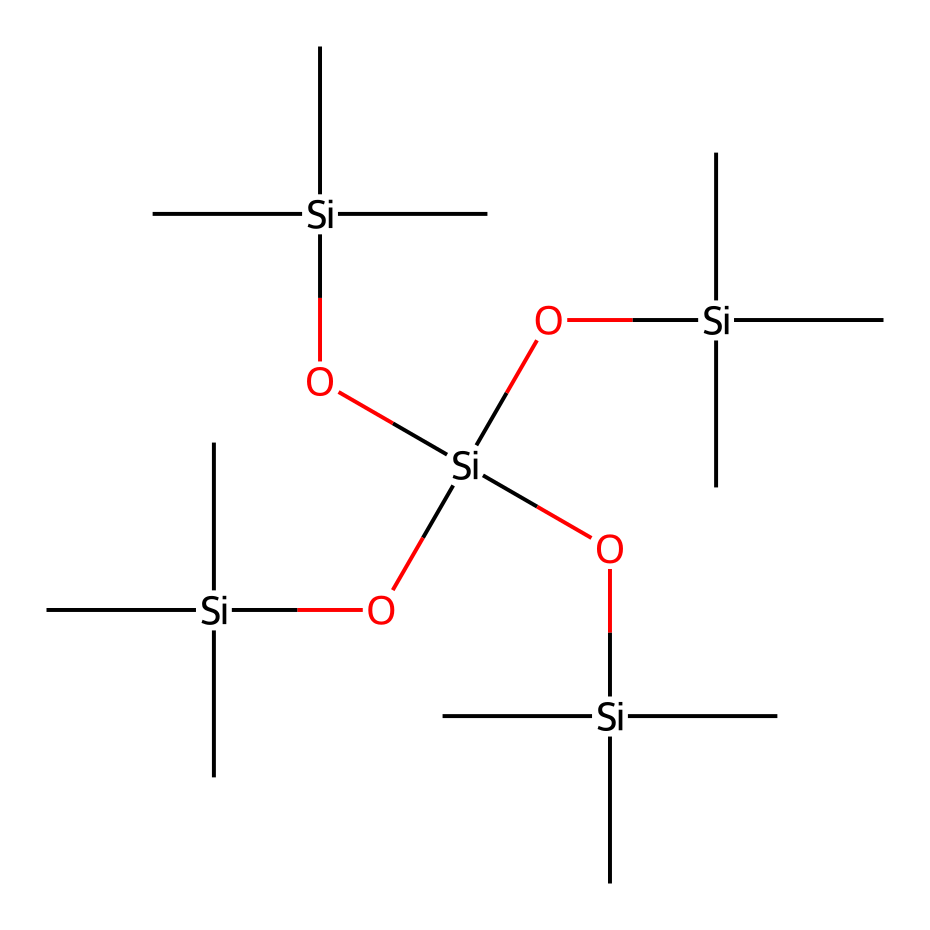What is the central atom of this organosilicon compound? In the provided SMILES representation, the central atom that is repeatedly mentioned is silicon (Si), as indicated by the repeating occurrences of [Si].
Answer: silicon How many silicon atoms are present in this structure? By examining the SMILES, the [Si] notation appears five times, indicating there are five silicon atoms present in the overall structure.
Answer: five What type of functional groups are present in this organosilicon compound? The SMILES representation includes the notation O which represents hydroxyl (–OH) functional groups attached to the silicon atoms, indicating the presence of silanol groups.
Answer: silanol What feature contributes to its photo-resistant properties in makeup? The silicon-oxygen bonds (Si-O) in this organosilicon compound provide stability and durability, contributing to its resistance to degradation under light exposure, which is essential for long-lasting makeup.
Answer: silicon-oxygen bonds How many carbon atoms are present in the structure? By analyzing the substituents attached to each silicon, each [Si](C)(C)C indicates three carbon atoms. Since there are four such silicon centers, there are a total of 12 carbon atoms.
Answer: twelve What is the implication of having multiple silanol groups in this chemical structure? The presence of multiple silanol groups allows for better interaction with skin surfaces, enhancing the adhesion and longevity of the makeup applied, which is particularly important in fashion photography.
Answer: better adhesion Is this compound likely to be hydrophobic or hydrophilic? Given that it has multiple silanol groups and silicon atoms, it likely has both hydrophobic and hydrophilic characteristics, but the silicon framework generally lends it a more hydrophobic nature, ideal for repelling water.
Answer: hydrophobic 